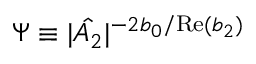Convert formula to latex. <formula><loc_0><loc_0><loc_500><loc_500>\Psi \equiv | \hat { A _ { 2 } } | ^ { - 2 b _ { 0 } / R e ( b _ { 2 } ) }</formula> 